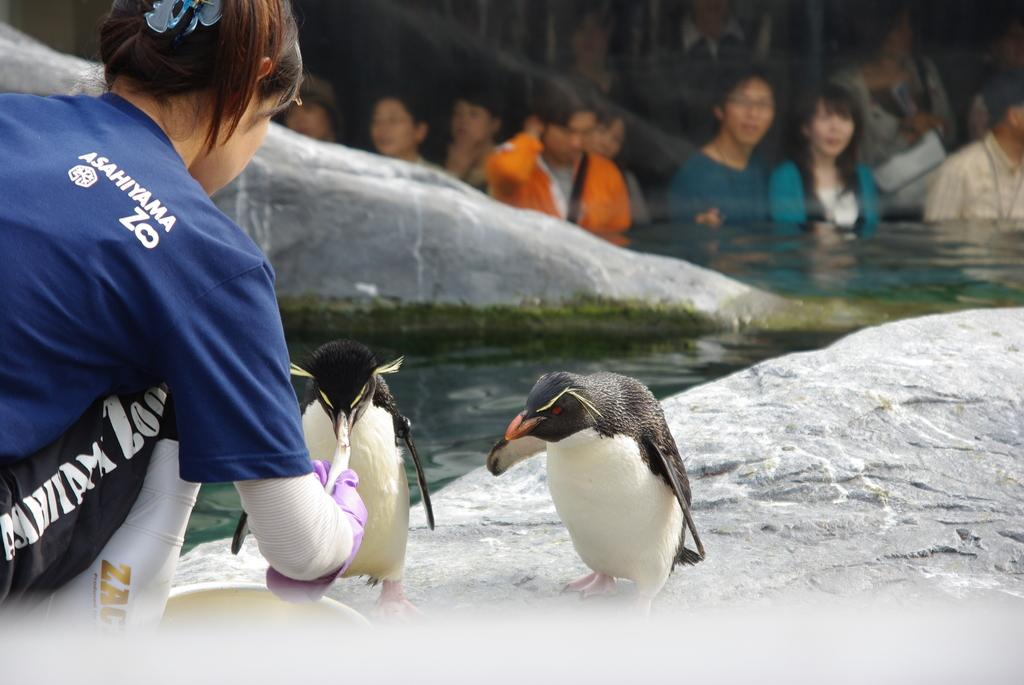What is the woman in the image doing? The woman is feeding penguins in the image. Where are the penguins located? The penguins are in a zoo enclosure. Are there any other people present in the image? Yes, there are people watching the penguins from a distance. What type of prose can be heard being read to the penguins in the image? There is no indication in the image that any prose is being read to the penguins. Can you describe the road leading to the penguin enclosure in the image? There is no road visible in the image; it only shows the woman feeding penguins and people watching from a distance. 